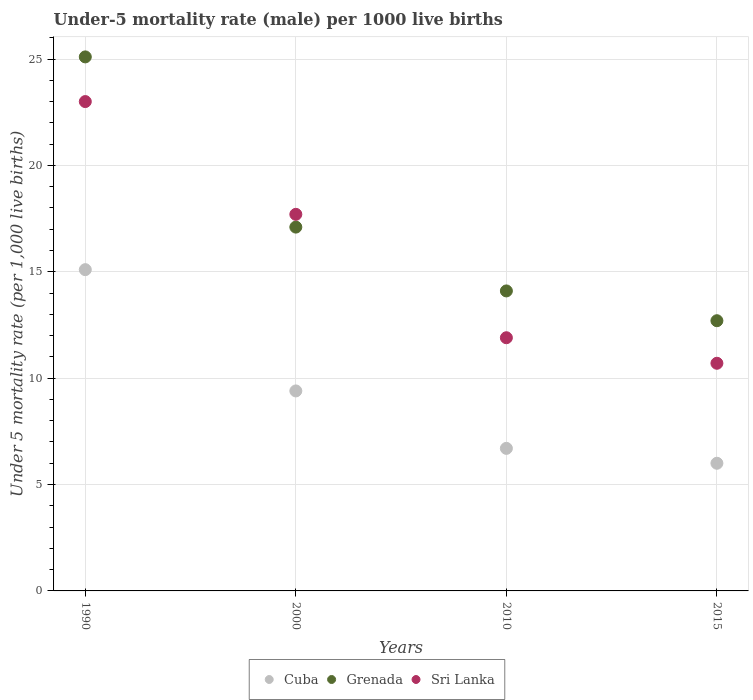How many different coloured dotlines are there?
Keep it short and to the point. 3. Is the number of dotlines equal to the number of legend labels?
Offer a very short reply. Yes. Across all years, what is the minimum under-five mortality rate in Cuba?
Your answer should be compact. 6. In which year was the under-five mortality rate in Grenada maximum?
Provide a succinct answer. 1990. In which year was the under-five mortality rate in Cuba minimum?
Your response must be concise. 2015. What is the total under-five mortality rate in Grenada in the graph?
Offer a very short reply. 69. What is the difference between the under-five mortality rate in Cuba in 1990 and that in 2010?
Offer a terse response. 8.4. What is the difference between the under-five mortality rate in Sri Lanka in 2015 and the under-five mortality rate in Grenada in 1990?
Offer a very short reply. -14.4. What is the average under-five mortality rate in Grenada per year?
Give a very brief answer. 17.25. In how many years, is the under-five mortality rate in Sri Lanka greater than 14?
Provide a succinct answer. 2. What is the ratio of the under-five mortality rate in Grenada in 1990 to that in 2015?
Your answer should be compact. 1.98. Is the under-five mortality rate in Cuba in 1990 less than that in 2015?
Keep it short and to the point. No. Is the difference between the under-five mortality rate in Grenada in 1990 and 2010 greater than the difference between the under-five mortality rate in Sri Lanka in 1990 and 2010?
Provide a short and direct response. No. In how many years, is the under-five mortality rate in Cuba greater than the average under-five mortality rate in Cuba taken over all years?
Provide a short and direct response. 2. Is the under-five mortality rate in Sri Lanka strictly greater than the under-five mortality rate in Cuba over the years?
Give a very brief answer. Yes. How many years are there in the graph?
Your response must be concise. 4. What is the difference between two consecutive major ticks on the Y-axis?
Your answer should be compact. 5. Are the values on the major ticks of Y-axis written in scientific E-notation?
Your response must be concise. No. Does the graph contain any zero values?
Offer a very short reply. No. How many legend labels are there?
Keep it short and to the point. 3. How are the legend labels stacked?
Your answer should be very brief. Horizontal. What is the title of the graph?
Your answer should be compact. Under-5 mortality rate (male) per 1000 live births. Does "Angola" appear as one of the legend labels in the graph?
Offer a terse response. No. What is the label or title of the Y-axis?
Offer a very short reply. Under 5 mortality rate (per 1,0 live births). What is the Under 5 mortality rate (per 1,000 live births) of Cuba in 1990?
Offer a very short reply. 15.1. What is the Under 5 mortality rate (per 1,000 live births) in Grenada in 1990?
Ensure brevity in your answer.  25.1. What is the Under 5 mortality rate (per 1,000 live births) of Grenada in 2000?
Provide a succinct answer. 17.1. What is the Under 5 mortality rate (per 1,000 live births) of Cuba in 2010?
Your response must be concise. 6.7. What is the Under 5 mortality rate (per 1,000 live births) of Grenada in 2010?
Your answer should be compact. 14.1. Across all years, what is the maximum Under 5 mortality rate (per 1,000 live births) of Cuba?
Keep it short and to the point. 15.1. Across all years, what is the maximum Under 5 mortality rate (per 1,000 live births) in Grenada?
Your answer should be very brief. 25.1. Across all years, what is the maximum Under 5 mortality rate (per 1,000 live births) in Sri Lanka?
Make the answer very short. 23. Across all years, what is the minimum Under 5 mortality rate (per 1,000 live births) of Cuba?
Your answer should be compact. 6. Across all years, what is the minimum Under 5 mortality rate (per 1,000 live births) in Grenada?
Give a very brief answer. 12.7. What is the total Under 5 mortality rate (per 1,000 live births) of Cuba in the graph?
Ensure brevity in your answer.  37.2. What is the total Under 5 mortality rate (per 1,000 live births) in Grenada in the graph?
Keep it short and to the point. 69. What is the total Under 5 mortality rate (per 1,000 live births) in Sri Lanka in the graph?
Give a very brief answer. 63.3. What is the difference between the Under 5 mortality rate (per 1,000 live births) in Cuba in 1990 and that in 2000?
Make the answer very short. 5.7. What is the difference between the Under 5 mortality rate (per 1,000 live births) in Grenada in 1990 and that in 2000?
Ensure brevity in your answer.  8. What is the difference between the Under 5 mortality rate (per 1,000 live births) in Sri Lanka in 1990 and that in 2000?
Your answer should be compact. 5.3. What is the difference between the Under 5 mortality rate (per 1,000 live births) in Sri Lanka in 1990 and that in 2015?
Keep it short and to the point. 12.3. What is the difference between the Under 5 mortality rate (per 1,000 live births) of Cuba in 2000 and that in 2010?
Your response must be concise. 2.7. What is the difference between the Under 5 mortality rate (per 1,000 live births) of Sri Lanka in 2000 and that in 2010?
Offer a very short reply. 5.8. What is the difference between the Under 5 mortality rate (per 1,000 live births) in Sri Lanka in 2000 and that in 2015?
Give a very brief answer. 7. What is the difference between the Under 5 mortality rate (per 1,000 live births) in Cuba in 2010 and that in 2015?
Offer a very short reply. 0.7. What is the difference between the Under 5 mortality rate (per 1,000 live births) of Grenada in 2010 and that in 2015?
Your answer should be compact. 1.4. What is the difference between the Under 5 mortality rate (per 1,000 live births) of Sri Lanka in 2010 and that in 2015?
Offer a very short reply. 1.2. What is the difference between the Under 5 mortality rate (per 1,000 live births) of Cuba in 1990 and the Under 5 mortality rate (per 1,000 live births) of Sri Lanka in 2000?
Give a very brief answer. -2.6. What is the difference between the Under 5 mortality rate (per 1,000 live births) of Cuba in 1990 and the Under 5 mortality rate (per 1,000 live births) of Grenada in 2010?
Ensure brevity in your answer.  1. What is the difference between the Under 5 mortality rate (per 1,000 live births) in Cuba in 1990 and the Under 5 mortality rate (per 1,000 live births) in Grenada in 2015?
Keep it short and to the point. 2.4. What is the difference between the Under 5 mortality rate (per 1,000 live births) of Cuba in 1990 and the Under 5 mortality rate (per 1,000 live births) of Sri Lanka in 2015?
Give a very brief answer. 4.4. What is the difference between the Under 5 mortality rate (per 1,000 live births) of Grenada in 1990 and the Under 5 mortality rate (per 1,000 live births) of Sri Lanka in 2015?
Offer a very short reply. 14.4. What is the difference between the Under 5 mortality rate (per 1,000 live births) in Cuba in 2000 and the Under 5 mortality rate (per 1,000 live births) in Grenada in 2010?
Offer a very short reply. -4.7. What is the difference between the Under 5 mortality rate (per 1,000 live births) in Cuba in 2000 and the Under 5 mortality rate (per 1,000 live births) in Grenada in 2015?
Your response must be concise. -3.3. What is the difference between the Under 5 mortality rate (per 1,000 live births) in Cuba in 2000 and the Under 5 mortality rate (per 1,000 live births) in Sri Lanka in 2015?
Offer a terse response. -1.3. What is the difference between the Under 5 mortality rate (per 1,000 live births) of Cuba in 2010 and the Under 5 mortality rate (per 1,000 live births) of Sri Lanka in 2015?
Offer a terse response. -4. What is the difference between the Under 5 mortality rate (per 1,000 live births) in Grenada in 2010 and the Under 5 mortality rate (per 1,000 live births) in Sri Lanka in 2015?
Provide a succinct answer. 3.4. What is the average Under 5 mortality rate (per 1,000 live births) in Cuba per year?
Offer a terse response. 9.3. What is the average Under 5 mortality rate (per 1,000 live births) of Grenada per year?
Keep it short and to the point. 17.25. What is the average Under 5 mortality rate (per 1,000 live births) in Sri Lanka per year?
Offer a terse response. 15.82. In the year 2000, what is the difference between the Under 5 mortality rate (per 1,000 live births) in Cuba and Under 5 mortality rate (per 1,000 live births) in Grenada?
Keep it short and to the point. -7.7. In the year 2010, what is the difference between the Under 5 mortality rate (per 1,000 live births) of Grenada and Under 5 mortality rate (per 1,000 live births) of Sri Lanka?
Ensure brevity in your answer.  2.2. In the year 2015, what is the difference between the Under 5 mortality rate (per 1,000 live births) in Cuba and Under 5 mortality rate (per 1,000 live births) in Grenada?
Your response must be concise. -6.7. What is the ratio of the Under 5 mortality rate (per 1,000 live births) of Cuba in 1990 to that in 2000?
Make the answer very short. 1.61. What is the ratio of the Under 5 mortality rate (per 1,000 live births) in Grenada in 1990 to that in 2000?
Your answer should be compact. 1.47. What is the ratio of the Under 5 mortality rate (per 1,000 live births) of Sri Lanka in 1990 to that in 2000?
Your answer should be very brief. 1.3. What is the ratio of the Under 5 mortality rate (per 1,000 live births) of Cuba in 1990 to that in 2010?
Your answer should be compact. 2.25. What is the ratio of the Under 5 mortality rate (per 1,000 live births) in Grenada in 1990 to that in 2010?
Your answer should be compact. 1.78. What is the ratio of the Under 5 mortality rate (per 1,000 live births) in Sri Lanka in 1990 to that in 2010?
Give a very brief answer. 1.93. What is the ratio of the Under 5 mortality rate (per 1,000 live births) in Cuba in 1990 to that in 2015?
Provide a succinct answer. 2.52. What is the ratio of the Under 5 mortality rate (per 1,000 live births) in Grenada in 1990 to that in 2015?
Your answer should be very brief. 1.98. What is the ratio of the Under 5 mortality rate (per 1,000 live births) in Sri Lanka in 1990 to that in 2015?
Offer a terse response. 2.15. What is the ratio of the Under 5 mortality rate (per 1,000 live births) in Cuba in 2000 to that in 2010?
Give a very brief answer. 1.4. What is the ratio of the Under 5 mortality rate (per 1,000 live births) of Grenada in 2000 to that in 2010?
Offer a very short reply. 1.21. What is the ratio of the Under 5 mortality rate (per 1,000 live births) in Sri Lanka in 2000 to that in 2010?
Offer a very short reply. 1.49. What is the ratio of the Under 5 mortality rate (per 1,000 live births) of Cuba in 2000 to that in 2015?
Provide a short and direct response. 1.57. What is the ratio of the Under 5 mortality rate (per 1,000 live births) of Grenada in 2000 to that in 2015?
Your answer should be compact. 1.35. What is the ratio of the Under 5 mortality rate (per 1,000 live births) in Sri Lanka in 2000 to that in 2015?
Your answer should be very brief. 1.65. What is the ratio of the Under 5 mortality rate (per 1,000 live births) in Cuba in 2010 to that in 2015?
Give a very brief answer. 1.12. What is the ratio of the Under 5 mortality rate (per 1,000 live births) of Grenada in 2010 to that in 2015?
Ensure brevity in your answer.  1.11. What is the ratio of the Under 5 mortality rate (per 1,000 live births) of Sri Lanka in 2010 to that in 2015?
Give a very brief answer. 1.11. What is the difference between the highest and the second highest Under 5 mortality rate (per 1,000 live births) of Cuba?
Provide a short and direct response. 5.7. What is the difference between the highest and the second highest Under 5 mortality rate (per 1,000 live births) of Sri Lanka?
Keep it short and to the point. 5.3. What is the difference between the highest and the lowest Under 5 mortality rate (per 1,000 live births) of Cuba?
Your response must be concise. 9.1. What is the difference between the highest and the lowest Under 5 mortality rate (per 1,000 live births) of Grenada?
Your answer should be very brief. 12.4. 